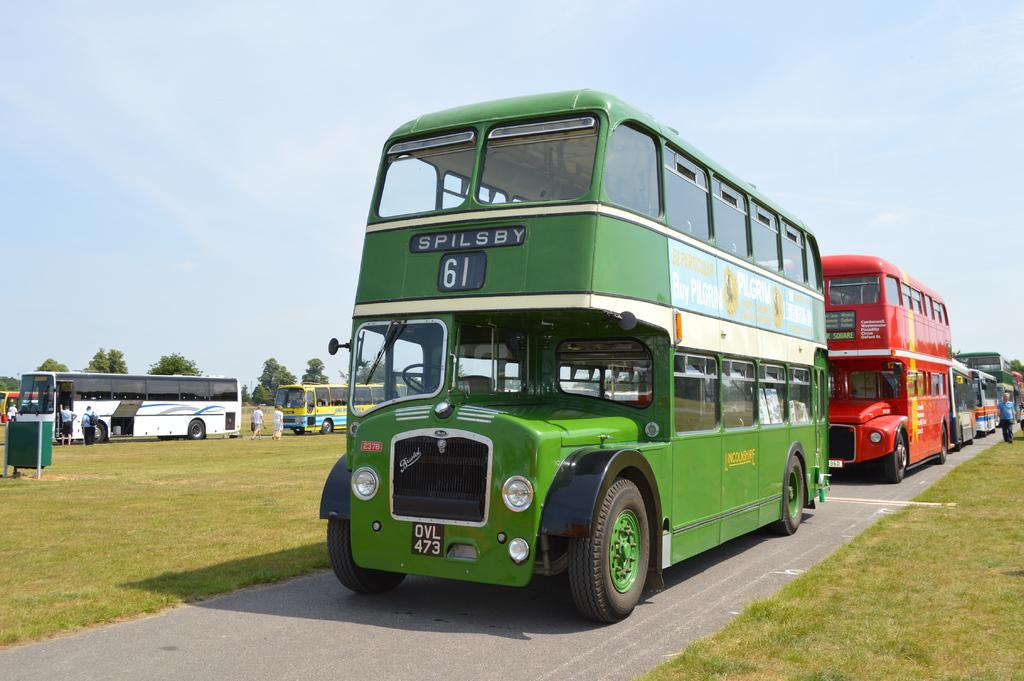<image>
Summarize the visual content of the image. A green double decker bus going to spilsby and marked number 61 infront of a red double decker bus. 